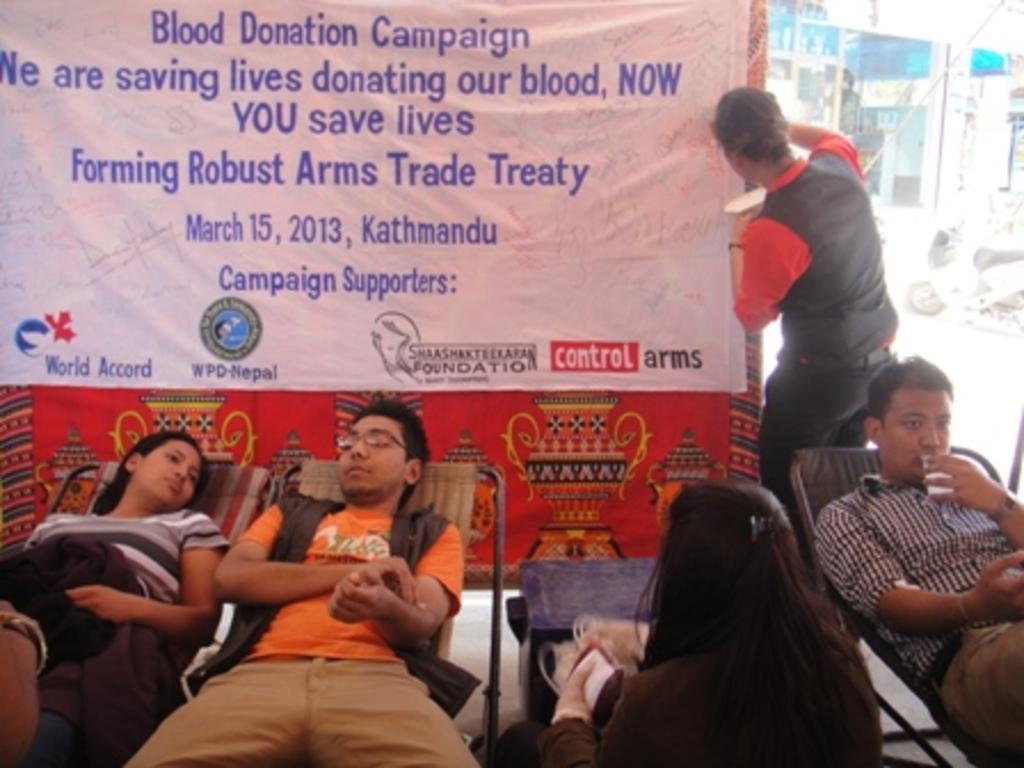Could you give a brief overview of what you see in this image? Here we can see three people laying on beds and the person on the right side is drinking something and there is woman sitting in between them and behind them we can see a banner being adjusted by a person and it is a blood donation campaign as we can see it 